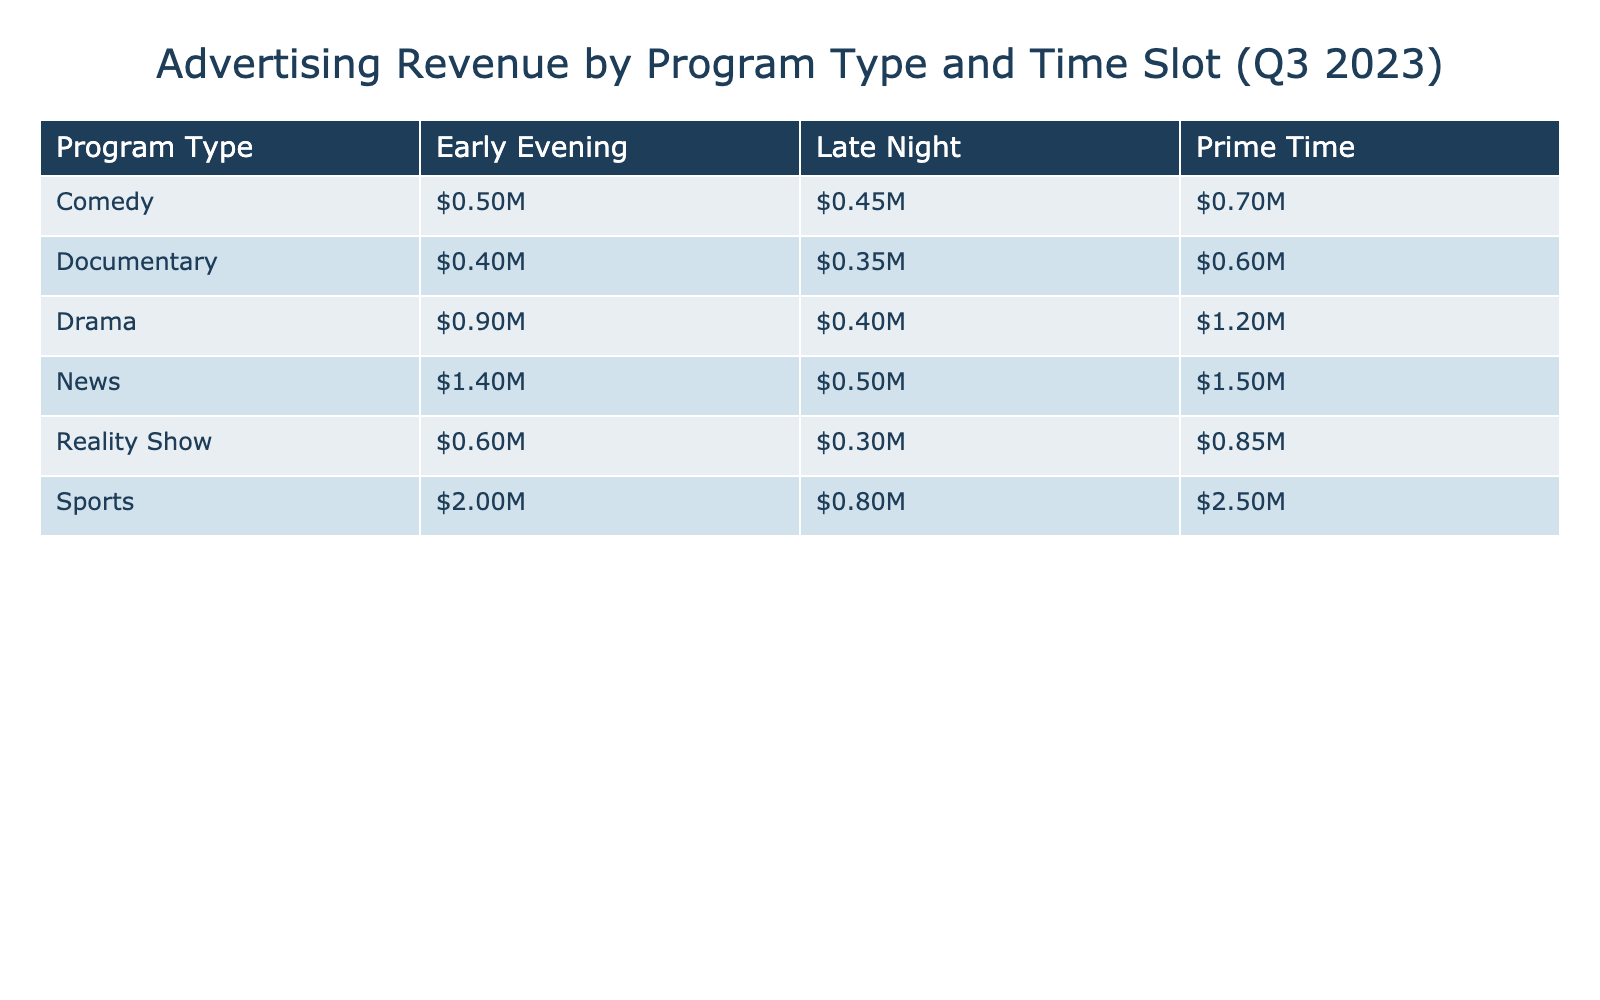What is the advertising revenue generated by Sports during Prime Time? From the table, the revenue for Sports in the Prime Time slot is explicitly listed as $2,500,000.
Answer: $2,500,000 Which program type generated the least advertising revenue in Late Night? In the Late Night time slot, Drama, Reality Show, News, Sports, Comedy, and Documentary all have revenues. The lowest value among these is Documentary at $350,000.
Answer: Documentary What is the total advertising revenue for Reality Shows across all time slots? The revenue for Reality Shows is $850,000 (Prime Time) + $300,000 (Late Night) + $600,000 (Early Evening) = $1,750,000.
Answer: $1,750,000 Did Comedy generate more revenue than Documentary in Early Evening? The revenue for Comedy in Early Evening is $500,000 and Documentary is $400,000. Since $500,000 is greater than $400,000, the statement is true.
Answer: Yes What is the average advertising revenue for News across all time slots? The total revenue for News is $1,500,000 (Prime Time) + $500,000 (Late Night) + $1,400,000 (Early Evening) = $3,400,000. There are 3 instances of News, so $3,400,000 divided by 3 equals $1,133,333.33, which can be rounded to $1,133,333.
Answer: $1,133,333 Which time slot had the highest total advertising revenue across all program types? To find this, we sum the advertising revenue for each time slot: Prime Time = $1,200,000 + $850,000 + $1,500,000 + $2,500,000 + $700,000 + $600,000 = $7,400,000; Late Night = $400,000 + $300,000 + $500,000 + $800,000 + $450,000 + $350,000 = $3,100,000; Early Evening = $900,000 + $600,000 + $1,400,000 + $2,000,000 + $500,000 + $400,000 = $6,800,000. Thus, Prime Time had the highest total revenue.
Answer: Prime Time Is the advertising revenue from Sports in Late Night greater than the combined revenue from Drama and Comedy in Prime Time? Sports in Late Night is $800,000. The combined revenue for Drama ($1,200,000) and Comedy ($700,000) in Prime Time is $1,900,000. Since $800,000 is less than $1,900,000, the statement is false.
Answer: No What is the difference in advertising revenue between the highest and lowest program types in Early Evening? In Early Evening, Sports generated the highest revenue of $2,000,000, while Documentary generated the lowest at $400,000. The difference is $2,000,000 - $400,000 = $1,600,000.
Answer: $1,600,000 